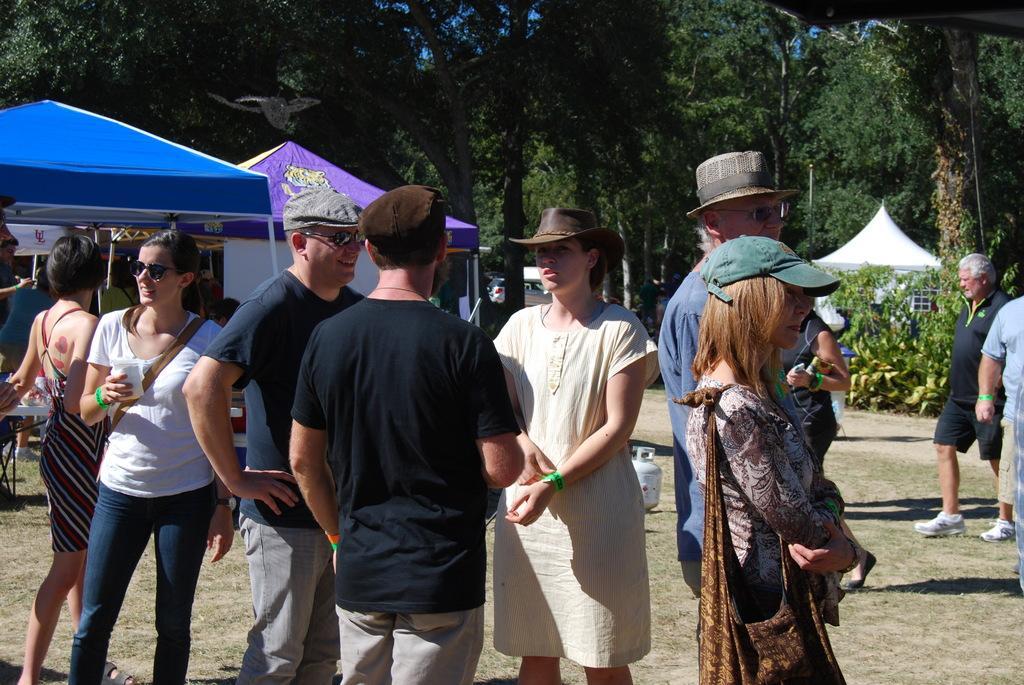Can you describe this image briefly? 2 Men are standing and speaking, they wore t-shirts. In the right side a beautiful girl is standing, she wore a ha, the left side there are tents. In the long back side there are trees. 